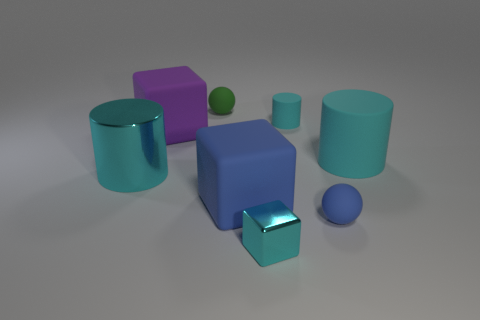Add 1 tiny cyan cylinders. How many objects exist? 9 Subtract all tiny cyan blocks. How many blocks are left? 2 Subtract all green balls. Subtract all cyan cylinders. How many balls are left? 1 Subtract all gray balls. How many cyan blocks are left? 1 Subtract all tiny cyan rubber things. Subtract all big green rubber objects. How many objects are left? 7 Add 6 small cyan matte things. How many small cyan matte things are left? 7 Add 7 matte spheres. How many matte spheres exist? 9 Subtract all purple blocks. How many blocks are left? 2 Subtract 0 yellow spheres. How many objects are left? 8 Subtract all cylinders. How many objects are left? 5 